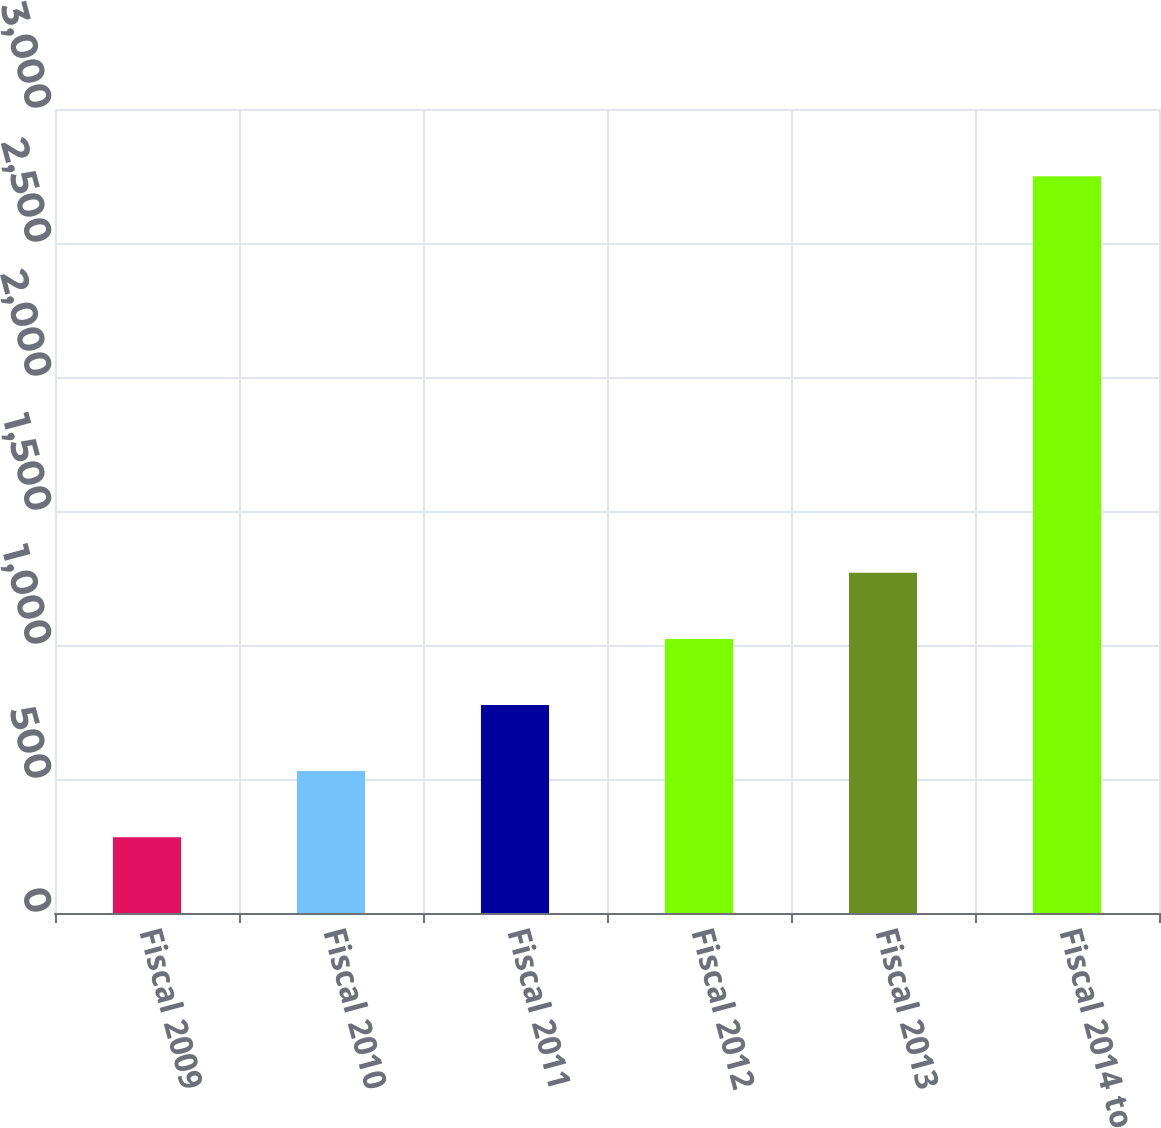<chart> <loc_0><loc_0><loc_500><loc_500><bar_chart><fcel>Fiscal 2009<fcel>Fiscal 2010<fcel>Fiscal 2011<fcel>Fiscal 2012<fcel>Fiscal 2013<fcel>Fiscal 2014 to 2018<nl><fcel>283<fcel>529.6<fcel>776.2<fcel>1022.8<fcel>1269.4<fcel>2749<nl></chart> 